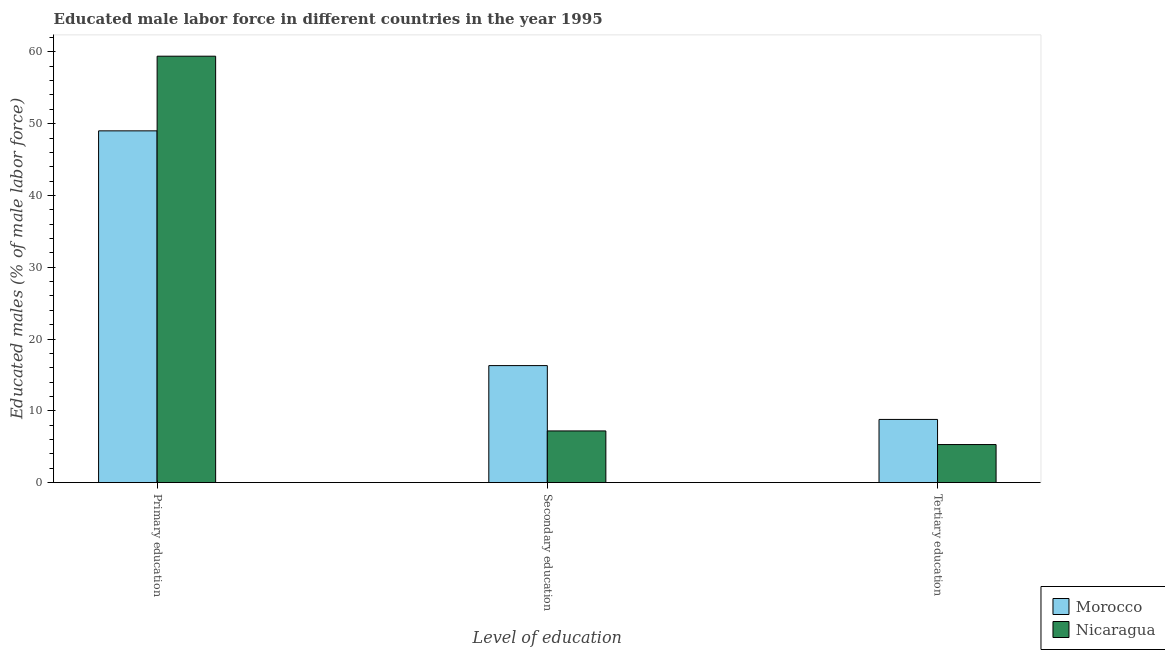Are the number of bars per tick equal to the number of legend labels?
Give a very brief answer. Yes. Are the number of bars on each tick of the X-axis equal?
Your response must be concise. Yes. How many bars are there on the 1st tick from the right?
Ensure brevity in your answer.  2. What is the label of the 3rd group of bars from the left?
Offer a terse response. Tertiary education. What is the percentage of male labor force who received tertiary education in Nicaragua?
Provide a succinct answer. 5.3. Across all countries, what is the maximum percentage of male labor force who received tertiary education?
Make the answer very short. 8.8. Across all countries, what is the minimum percentage of male labor force who received tertiary education?
Ensure brevity in your answer.  5.3. In which country was the percentage of male labor force who received secondary education maximum?
Offer a very short reply. Morocco. In which country was the percentage of male labor force who received secondary education minimum?
Provide a short and direct response. Nicaragua. What is the total percentage of male labor force who received secondary education in the graph?
Your response must be concise. 23.5. What is the difference between the percentage of male labor force who received tertiary education in Nicaragua and that in Morocco?
Keep it short and to the point. -3.5. What is the difference between the percentage of male labor force who received primary education in Nicaragua and the percentage of male labor force who received tertiary education in Morocco?
Your answer should be compact. 50.6. What is the average percentage of male labor force who received tertiary education per country?
Your answer should be very brief. 7.05. What is the difference between the percentage of male labor force who received primary education and percentage of male labor force who received tertiary education in Morocco?
Your answer should be very brief. 40.2. What is the ratio of the percentage of male labor force who received tertiary education in Nicaragua to that in Morocco?
Give a very brief answer. 0.6. What is the difference between the highest and the second highest percentage of male labor force who received secondary education?
Make the answer very short. 9.1. What is the difference between the highest and the lowest percentage of male labor force who received secondary education?
Provide a succinct answer. 9.1. In how many countries, is the percentage of male labor force who received primary education greater than the average percentage of male labor force who received primary education taken over all countries?
Offer a terse response. 1. What does the 1st bar from the left in Secondary education represents?
Keep it short and to the point. Morocco. What does the 1st bar from the right in Primary education represents?
Provide a short and direct response. Nicaragua. Are all the bars in the graph horizontal?
Give a very brief answer. No. How many countries are there in the graph?
Offer a terse response. 2. What is the difference between two consecutive major ticks on the Y-axis?
Offer a terse response. 10. Are the values on the major ticks of Y-axis written in scientific E-notation?
Your answer should be compact. No. Does the graph contain grids?
Your response must be concise. No. How many legend labels are there?
Your answer should be very brief. 2. How are the legend labels stacked?
Your answer should be compact. Vertical. What is the title of the graph?
Make the answer very short. Educated male labor force in different countries in the year 1995. Does "Eritrea" appear as one of the legend labels in the graph?
Make the answer very short. No. What is the label or title of the X-axis?
Your response must be concise. Level of education. What is the label or title of the Y-axis?
Give a very brief answer. Educated males (% of male labor force). What is the Educated males (% of male labor force) in Morocco in Primary education?
Provide a short and direct response. 49. What is the Educated males (% of male labor force) in Nicaragua in Primary education?
Ensure brevity in your answer.  59.4. What is the Educated males (% of male labor force) of Morocco in Secondary education?
Offer a very short reply. 16.3. What is the Educated males (% of male labor force) of Nicaragua in Secondary education?
Your answer should be compact. 7.2. What is the Educated males (% of male labor force) in Morocco in Tertiary education?
Make the answer very short. 8.8. What is the Educated males (% of male labor force) in Nicaragua in Tertiary education?
Give a very brief answer. 5.3. Across all Level of education, what is the maximum Educated males (% of male labor force) of Morocco?
Your answer should be compact. 49. Across all Level of education, what is the maximum Educated males (% of male labor force) in Nicaragua?
Make the answer very short. 59.4. Across all Level of education, what is the minimum Educated males (% of male labor force) in Morocco?
Offer a very short reply. 8.8. Across all Level of education, what is the minimum Educated males (% of male labor force) of Nicaragua?
Offer a very short reply. 5.3. What is the total Educated males (% of male labor force) of Morocco in the graph?
Offer a very short reply. 74.1. What is the total Educated males (% of male labor force) of Nicaragua in the graph?
Provide a short and direct response. 71.9. What is the difference between the Educated males (% of male labor force) of Morocco in Primary education and that in Secondary education?
Give a very brief answer. 32.7. What is the difference between the Educated males (% of male labor force) in Nicaragua in Primary education and that in Secondary education?
Provide a succinct answer. 52.2. What is the difference between the Educated males (% of male labor force) of Morocco in Primary education and that in Tertiary education?
Provide a succinct answer. 40.2. What is the difference between the Educated males (% of male labor force) of Nicaragua in Primary education and that in Tertiary education?
Make the answer very short. 54.1. What is the difference between the Educated males (% of male labor force) in Nicaragua in Secondary education and that in Tertiary education?
Give a very brief answer. 1.9. What is the difference between the Educated males (% of male labor force) of Morocco in Primary education and the Educated males (% of male labor force) of Nicaragua in Secondary education?
Your answer should be very brief. 41.8. What is the difference between the Educated males (% of male labor force) in Morocco in Primary education and the Educated males (% of male labor force) in Nicaragua in Tertiary education?
Make the answer very short. 43.7. What is the difference between the Educated males (% of male labor force) in Morocco in Secondary education and the Educated males (% of male labor force) in Nicaragua in Tertiary education?
Give a very brief answer. 11. What is the average Educated males (% of male labor force) in Morocco per Level of education?
Provide a short and direct response. 24.7. What is the average Educated males (% of male labor force) of Nicaragua per Level of education?
Ensure brevity in your answer.  23.97. What is the difference between the Educated males (% of male labor force) of Morocco and Educated males (% of male labor force) of Nicaragua in Tertiary education?
Make the answer very short. 3.5. What is the ratio of the Educated males (% of male labor force) of Morocco in Primary education to that in Secondary education?
Keep it short and to the point. 3.01. What is the ratio of the Educated males (% of male labor force) in Nicaragua in Primary education to that in Secondary education?
Your answer should be compact. 8.25. What is the ratio of the Educated males (% of male labor force) of Morocco in Primary education to that in Tertiary education?
Make the answer very short. 5.57. What is the ratio of the Educated males (% of male labor force) in Nicaragua in Primary education to that in Tertiary education?
Make the answer very short. 11.21. What is the ratio of the Educated males (% of male labor force) in Morocco in Secondary education to that in Tertiary education?
Make the answer very short. 1.85. What is the ratio of the Educated males (% of male labor force) of Nicaragua in Secondary education to that in Tertiary education?
Keep it short and to the point. 1.36. What is the difference between the highest and the second highest Educated males (% of male labor force) in Morocco?
Provide a short and direct response. 32.7. What is the difference between the highest and the second highest Educated males (% of male labor force) of Nicaragua?
Provide a succinct answer. 52.2. What is the difference between the highest and the lowest Educated males (% of male labor force) in Morocco?
Ensure brevity in your answer.  40.2. What is the difference between the highest and the lowest Educated males (% of male labor force) in Nicaragua?
Offer a very short reply. 54.1. 